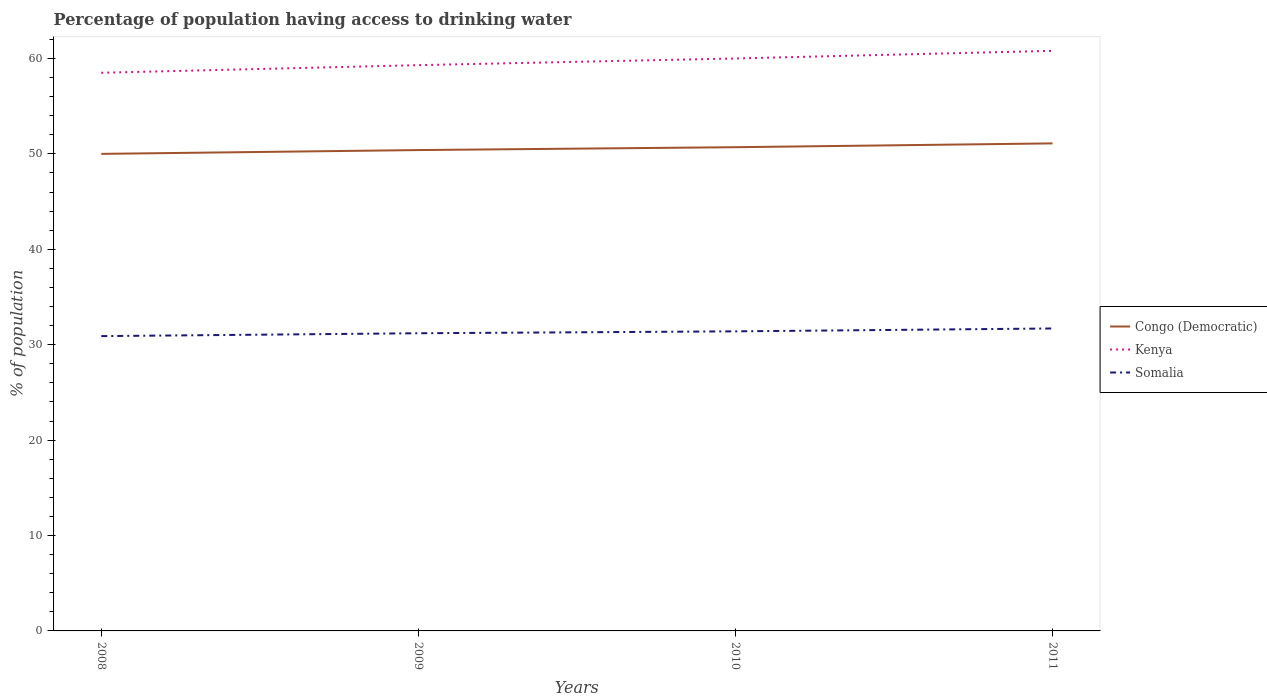Across all years, what is the maximum percentage of population having access to drinking water in Somalia?
Your answer should be compact. 30.9. What is the total percentage of population having access to drinking water in Congo (Democratic) in the graph?
Offer a terse response. -1.1. What is the difference between the highest and the second highest percentage of population having access to drinking water in Kenya?
Make the answer very short. 2.3. Is the percentage of population having access to drinking water in Somalia strictly greater than the percentage of population having access to drinking water in Kenya over the years?
Provide a short and direct response. Yes. How many lines are there?
Your answer should be very brief. 3. How many years are there in the graph?
Your response must be concise. 4. What is the difference between two consecutive major ticks on the Y-axis?
Provide a short and direct response. 10. Are the values on the major ticks of Y-axis written in scientific E-notation?
Provide a succinct answer. No. Does the graph contain grids?
Keep it short and to the point. No. How many legend labels are there?
Keep it short and to the point. 3. How are the legend labels stacked?
Your response must be concise. Vertical. What is the title of the graph?
Provide a short and direct response. Percentage of population having access to drinking water. Does "Liberia" appear as one of the legend labels in the graph?
Ensure brevity in your answer.  No. What is the label or title of the X-axis?
Ensure brevity in your answer.  Years. What is the label or title of the Y-axis?
Your answer should be very brief. % of population. What is the % of population of Congo (Democratic) in 2008?
Offer a terse response. 50. What is the % of population of Kenya in 2008?
Your response must be concise. 58.5. What is the % of population in Somalia in 2008?
Give a very brief answer. 30.9. What is the % of population of Congo (Democratic) in 2009?
Your answer should be very brief. 50.4. What is the % of population of Kenya in 2009?
Your answer should be compact. 59.3. What is the % of population of Somalia in 2009?
Keep it short and to the point. 31.2. What is the % of population of Congo (Democratic) in 2010?
Your answer should be compact. 50.7. What is the % of population in Somalia in 2010?
Your answer should be very brief. 31.4. What is the % of population of Congo (Democratic) in 2011?
Offer a terse response. 51.1. What is the % of population of Kenya in 2011?
Keep it short and to the point. 60.8. What is the % of population of Somalia in 2011?
Your answer should be compact. 31.7. Across all years, what is the maximum % of population in Congo (Democratic)?
Give a very brief answer. 51.1. Across all years, what is the maximum % of population in Kenya?
Make the answer very short. 60.8. Across all years, what is the maximum % of population in Somalia?
Your answer should be compact. 31.7. Across all years, what is the minimum % of population in Congo (Democratic)?
Make the answer very short. 50. Across all years, what is the minimum % of population in Kenya?
Ensure brevity in your answer.  58.5. Across all years, what is the minimum % of population of Somalia?
Your answer should be compact. 30.9. What is the total % of population in Congo (Democratic) in the graph?
Provide a succinct answer. 202.2. What is the total % of population of Kenya in the graph?
Provide a succinct answer. 238.6. What is the total % of population in Somalia in the graph?
Your answer should be compact. 125.2. What is the difference between the % of population of Kenya in 2008 and that in 2009?
Offer a very short reply. -0.8. What is the difference between the % of population in Kenya in 2008 and that in 2010?
Provide a short and direct response. -1.5. What is the difference between the % of population of Somalia in 2008 and that in 2011?
Make the answer very short. -0.8. What is the difference between the % of population of Kenya in 2009 and that in 2011?
Keep it short and to the point. -1.5. What is the difference between the % of population of Somalia in 2009 and that in 2011?
Keep it short and to the point. -0.5. What is the difference between the % of population of Congo (Democratic) in 2010 and that in 2011?
Ensure brevity in your answer.  -0.4. What is the difference between the % of population in Kenya in 2010 and that in 2011?
Offer a terse response. -0.8. What is the difference between the % of population in Congo (Democratic) in 2008 and the % of population in Kenya in 2009?
Keep it short and to the point. -9.3. What is the difference between the % of population of Congo (Democratic) in 2008 and the % of population of Somalia in 2009?
Ensure brevity in your answer.  18.8. What is the difference between the % of population of Kenya in 2008 and the % of population of Somalia in 2009?
Keep it short and to the point. 27.3. What is the difference between the % of population in Congo (Democratic) in 2008 and the % of population in Kenya in 2010?
Offer a very short reply. -10. What is the difference between the % of population of Kenya in 2008 and the % of population of Somalia in 2010?
Provide a succinct answer. 27.1. What is the difference between the % of population of Kenya in 2008 and the % of population of Somalia in 2011?
Give a very brief answer. 26.8. What is the difference between the % of population in Congo (Democratic) in 2009 and the % of population in Somalia in 2010?
Provide a succinct answer. 19. What is the difference between the % of population of Kenya in 2009 and the % of population of Somalia in 2010?
Offer a very short reply. 27.9. What is the difference between the % of population of Congo (Democratic) in 2009 and the % of population of Kenya in 2011?
Provide a short and direct response. -10.4. What is the difference between the % of population in Congo (Democratic) in 2009 and the % of population in Somalia in 2011?
Offer a very short reply. 18.7. What is the difference between the % of population of Kenya in 2009 and the % of population of Somalia in 2011?
Your answer should be very brief. 27.6. What is the difference between the % of population of Congo (Democratic) in 2010 and the % of population of Kenya in 2011?
Provide a succinct answer. -10.1. What is the difference between the % of population in Congo (Democratic) in 2010 and the % of population in Somalia in 2011?
Ensure brevity in your answer.  19. What is the difference between the % of population of Kenya in 2010 and the % of population of Somalia in 2011?
Provide a short and direct response. 28.3. What is the average % of population in Congo (Democratic) per year?
Provide a succinct answer. 50.55. What is the average % of population in Kenya per year?
Offer a terse response. 59.65. What is the average % of population of Somalia per year?
Keep it short and to the point. 31.3. In the year 2008, what is the difference between the % of population of Congo (Democratic) and % of population of Somalia?
Your answer should be compact. 19.1. In the year 2008, what is the difference between the % of population of Kenya and % of population of Somalia?
Give a very brief answer. 27.6. In the year 2009, what is the difference between the % of population of Congo (Democratic) and % of population of Somalia?
Offer a very short reply. 19.2. In the year 2009, what is the difference between the % of population in Kenya and % of population in Somalia?
Your response must be concise. 28.1. In the year 2010, what is the difference between the % of population in Congo (Democratic) and % of population in Somalia?
Your response must be concise. 19.3. In the year 2010, what is the difference between the % of population in Kenya and % of population in Somalia?
Offer a terse response. 28.6. In the year 2011, what is the difference between the % of population in Congo (Democratic) and % of population in Kenya?
Offer a very short reply. -9.7. In the year 2011, what is the difference between the % of population of Kenya and % of population of Somalia?
Your response must be concise. 29.1. What is the ratio of the % of population in Congo (Democratic) in 2008 to that in 2009?
Provide a short and direct response. 0.99. What is the ratio of the % of population in Kenya in 2008 to that in 2009?
Provide a short and direct response. 0.99. What is the ratio of the % of population in Congo (Democratic) in 2008 to that in 2010?
Offer a very short reply. 0.99. What is the ratio of the % of population of Kenya in 2008 to that in 2010?
Your response must be concise. 0.97. What is the ratio of the % of population of Somalia in 2008 to that in 2010?
Keep it short and to the point. 0.98. What is the ratio of the % of population of Congo (Democratic) in 2008 to that in 2011?
Your response must be concise. 0.98. What is the ratio of the % of population of Kenya in 2008 to that in 2011?
Your answer should be compact. 0.96. What is the ratio of the % of population of Somalia in 2008 to that in 2011?
Your response must be concise. 0.97. What is the ratio of the % of population in Congo (Democratic) in 2009 to that in 2010?
Provide a short and direct response. 0.99. What is the ratio of the % of population of Kenya in 2009 to that in 2010?
Keep it short and to the point. 0.99. What is the ratio of the % of population of Congo (Democratic) in 2009 to that in 2011?
Offer a terse response. 0.99. What is the ratio of the % of population in Kenya in 2009 to that in 2011?
Ensure brevity in your answer.  0.98. What is the ratio of the % of population in Somalia in 2009 to that in 2011?
Your answer should be very brief. 0.98. What is the difference between the highest and the lowest % of population of Congo (Democratic)?
Keep it short and to the point. 1.1. 